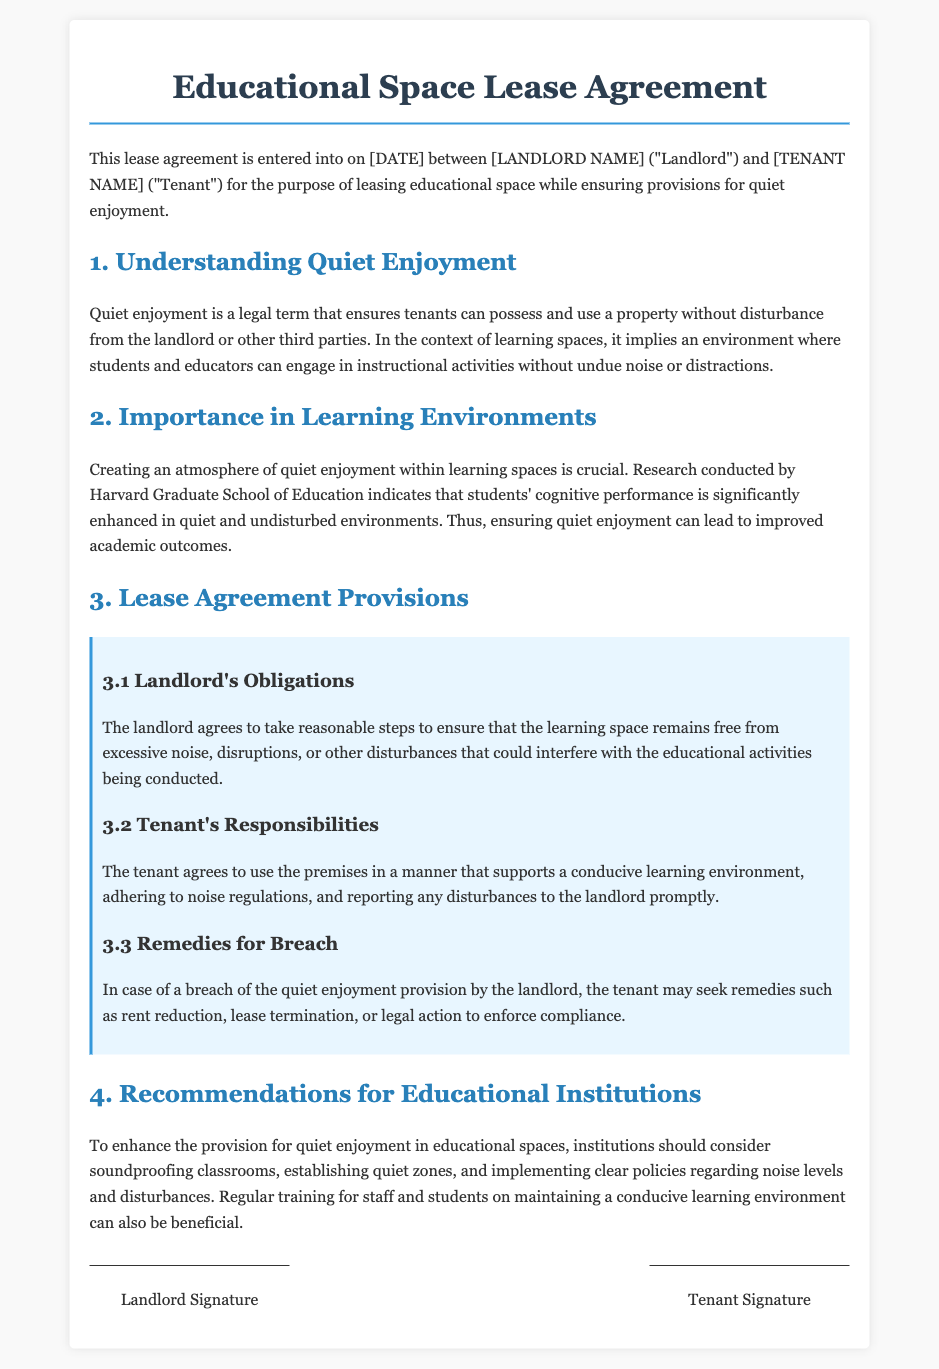What is the date when this lease agreement is entered into? The date is specified in the document as [DATE], which would be filled in at the time of signing.
Answer: [DATE] What does "quiet enjoyment" refer to? Quiet enjoyment refers to the legal term that ensures tenants can possess and use a property without disturbance.
Answer: Disturbance Who is responsible for noise regulations according to the tenant's responsibilities? The tenant agrees to use the premises in a manner that supports a conducive learning environment and adhere to noise regulations.
Answer: Tenant What does the landlord agree to do in relation to noise? The landlord agrees to take reasonable steps to ensure that the learning space remains free from excessive noise.
Answer: Excessive noise What are some recommended actions for educational institutions to enhance quiet enjoyment? The document suggests soundproofing classrooms, establishing quiet zones, and implementing clear policies.
Answer: Soundproofing classrooms What remedies can the tenant seek in case of a breach of quiet enjoyment provision? The tenant may seek remedies such as rent reduction, lease termination, or legal action.
Answer: Rent reduction Who conducted research on cognitive performance in education? The research referenced is conducted by Harvard Graduate School of Education.
Answer: Harvard Graduate School of Education What is the primary focus of the lease agreement? The primary focus is leasing educational space while ensuring provisions for quiet enjoyment.
Answer: Quiet enjoyment 